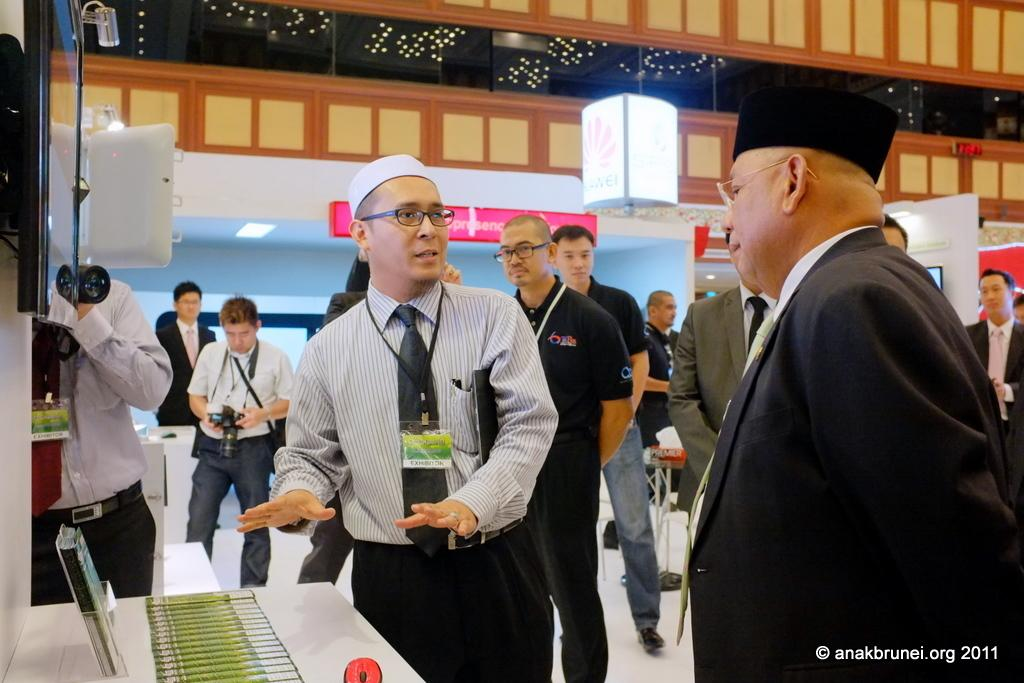What can be seen in the image involving people? There are people standing in the image. What type of animal is present in the image? There is a mouse in the image. What is located on the table in the image? There are objects on the table. What electronic devices are visible in the image? There is a camera and a television in the image. What can be seen in the background of the image? There is a wall, a light, and a board in the background of the image. How many seats are visible in the image? There are no seats present in the image. What type of beam is holding up the ceiling in the image? There is no beam visible in the image, as it only shows people, a mouse, objects on a table, electronic devices, and elements in the background. 